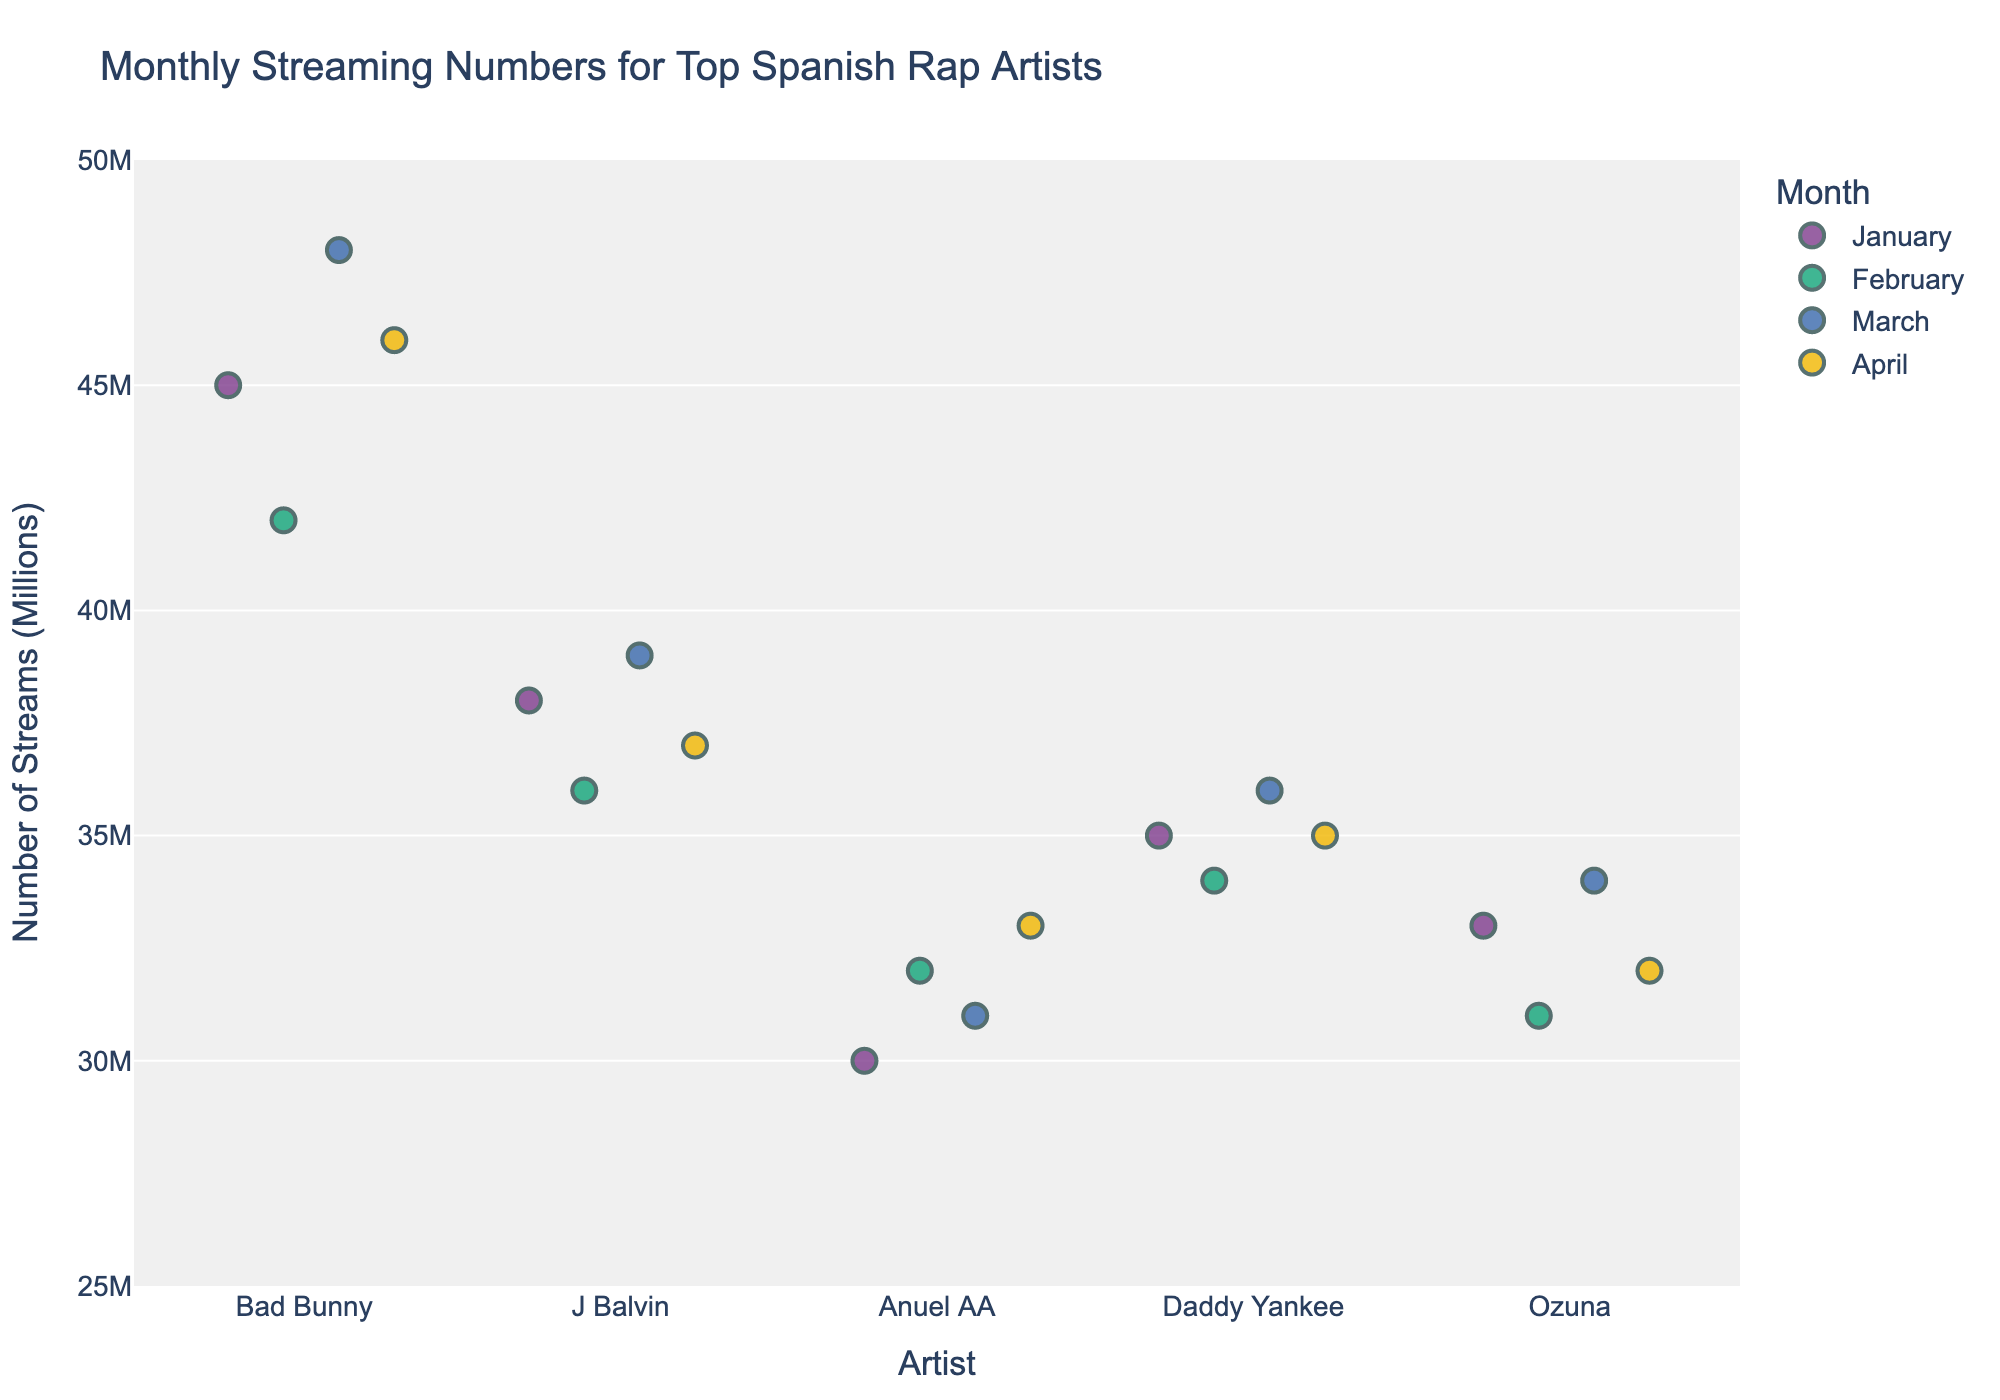What is the title of the plot? The title is usually found at the top of the plot. It describes the main topic or purpose of the figure. Here, the title is "Monthly Streaming Numbers for Top Spanish Rap Artists".
Answer: Monthly Streaming Numbers for Top Spanish Rap Artists How many top Spanish rap artists are represented in the plot? Each artist's name is listed on the x-axis of the plot. Counting them gives the total number. There are five artists: Bad Bunny, J Balvin, Anuel AA, Daddy Yankee, and Ozuna.
Answer: 5 Which artist had the highest number of streams in March? To find this, look at the data points for March, colored uniquely, and see which one is the highest on the y-axis. Bad Bunny had the highest number of streams in March with 48,000,000 streams.
Answer: Bad Bunny Who had more streams in February, J Balvin or Daddy Yankee? Compare the position of February's data points for both artists, J Balvin and Daddy Yankee, on the y-axis. J Balvin had 36,000,000 streams, and Daddy Yankee had 34,000,000 streams in February. Thus, J Balvin had more streams.
Answer: J Balvin What's the range of stream numbers for Ozuna from January to April? Identify the highest and lowest points for Ozuna across January to April. The highest is 34,000,000 (March), and the lowest is 31,000,000 (February). Subtract the lowest from the highest to get the range. So, 34M - 31M = 3M.
Answer: 3M Which month had the most variation in streaming numbers across all artists? Examine the spread of dots for each month and see which month shows the widest vertical dispersion in the y-axis. March shows the most variation, having a wide range from 31M (Anuel AA) to 48M (Bad Bunny).
Answer: March What's the average number of streams for Anuel AA over the first four months? Add the streams for January, February, March, and April, then divide by 4. The numbers are 30M, 32M, 31M, and 33M. The sum is 126M, so the average is 126M/4 = 31.5M.
Answer: 31.5M How does the streaming trend for Bad Bunny compare to Ozuna's from January to April? Look at the progression of data points for both artists from January to April. Bad Bunny's streams are generally higher and exhibit a consistent increase, while Ozuna's streams are lower overall and don't show a clear increasing or decreasing trend, peaking in March.
Answer: Bad Bunny increased, Ozuna fluctuated Who had the least number of streams in January? Find the January data points and compare their positions on the y-axis. Anuel AA had the lowest point at 30,000,000 streams in January.
Answer: Anuel AA 